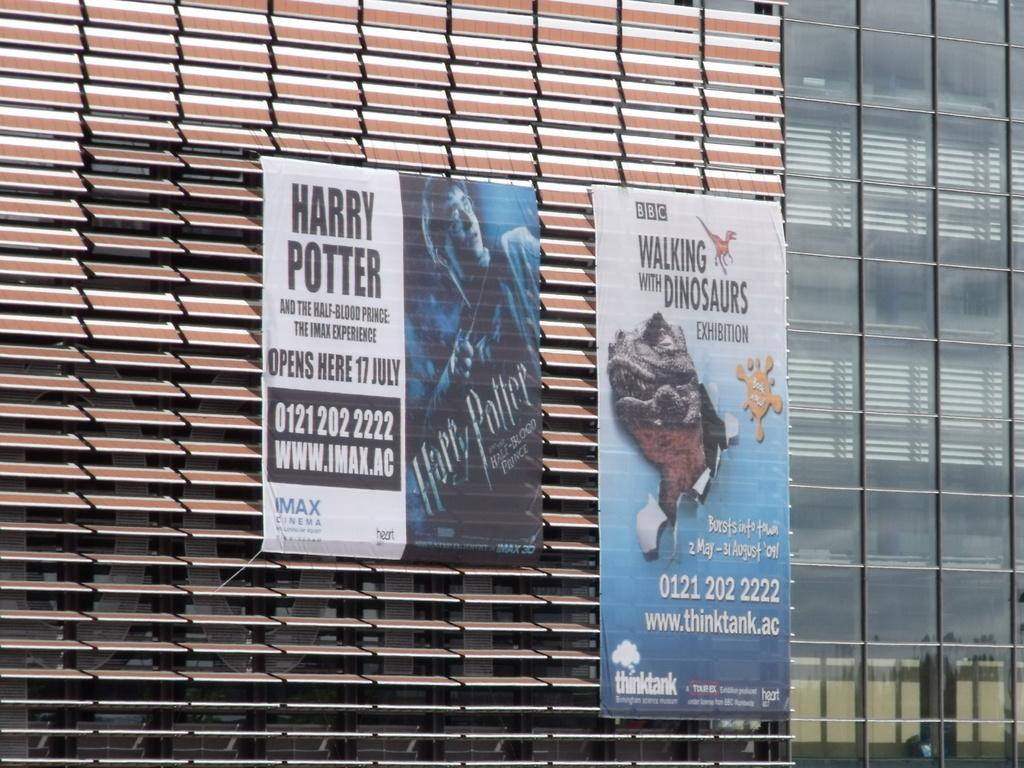Provide a one-sentence caption for the provided image. A sign advertises that Harry Potter is opening there in July. 